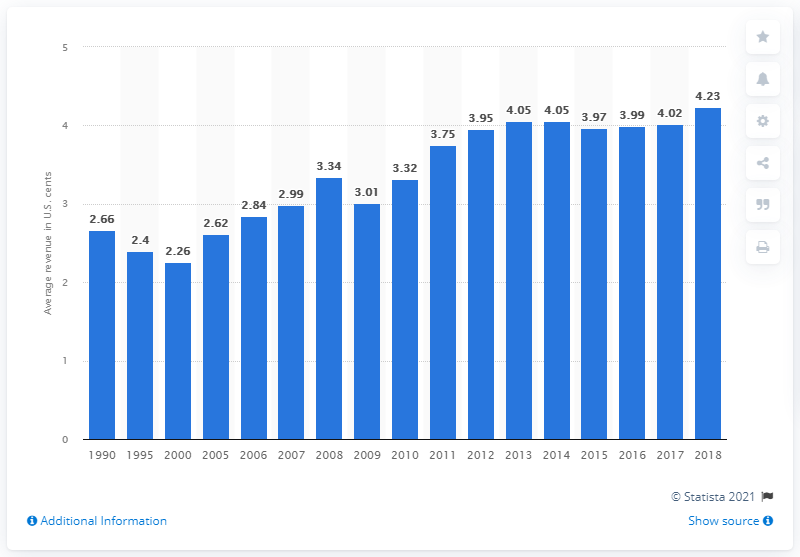Specify some key components in this picture. In 1990, the average freight revenue per ton-mile in Class I rail traffic was 4.23 U.S. dollar cents. In 1990, the average revenue earned from transporting a ton of cargo one mile by Class I railroads was 2.66 dollars. In 2018, the average revenue earned by Class I railroads in the United States for each ton-mile of freight traffic was 4.23 dollars. 